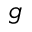<formula> <loc_0><loc_0><loc_500><loc_500>g</formula> 